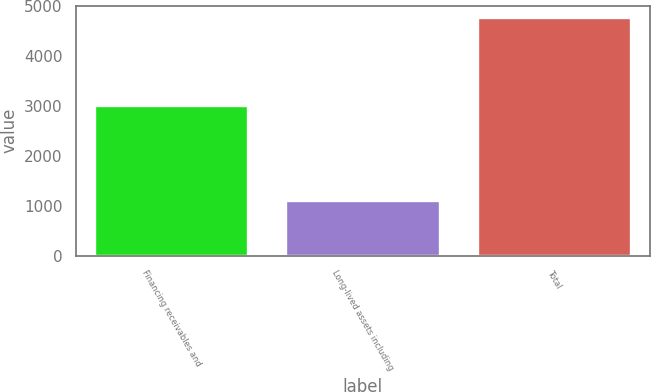<chart> <loc_0><loc_0><loc_500><loc_500><bar_chart><fcel>Financing receivables and<fcel>Long-lived assets including<fcel>Total<nl><fcel>2986<fcel>1088<fcel>4764<nl></chart> 